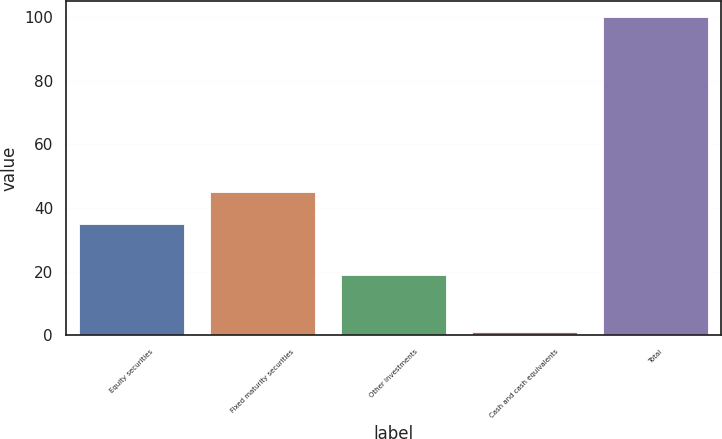Convert chart to OTSL. <chart><loc_0><loc_0><loc_500><loc_500><bar_chart><fcel>Equity securities<fcel>Fixed maturity securities<fcel>Other investments<fcel>Cash and cash equivalents<fcel>Total<nl><fcel>35<fcel>45<fcel>19<fcel>1<fcel>100<nl></chart> 